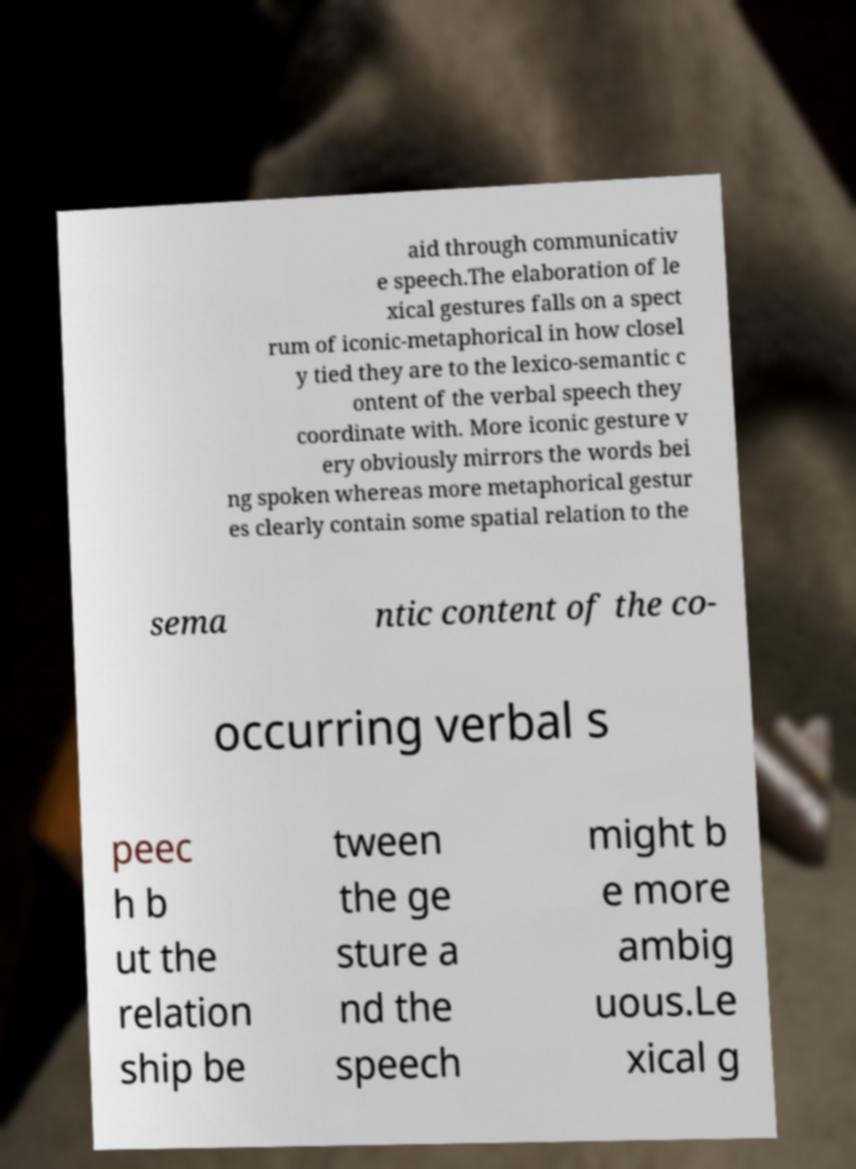For documentation purposes, I need the text within this image transcribed. Could you provide that? aid through communicativ e speech.The elaboration of le xical gestures falls on a spect rum of iconic-metaphorical in how closel y tied they are to the lexico-semantic c ontent of the verbal speech they coordinate with. More iconic gesture v ery obviously mirrors the words bei ng spoken whereas more metaphorical gestur es clearly contain some spatial relation to the sema ntic content of the co- occurring verbal s peec h b ut the relation ship be tween the ge sture a nd the speech might b e more ambig uous.Le xical g 